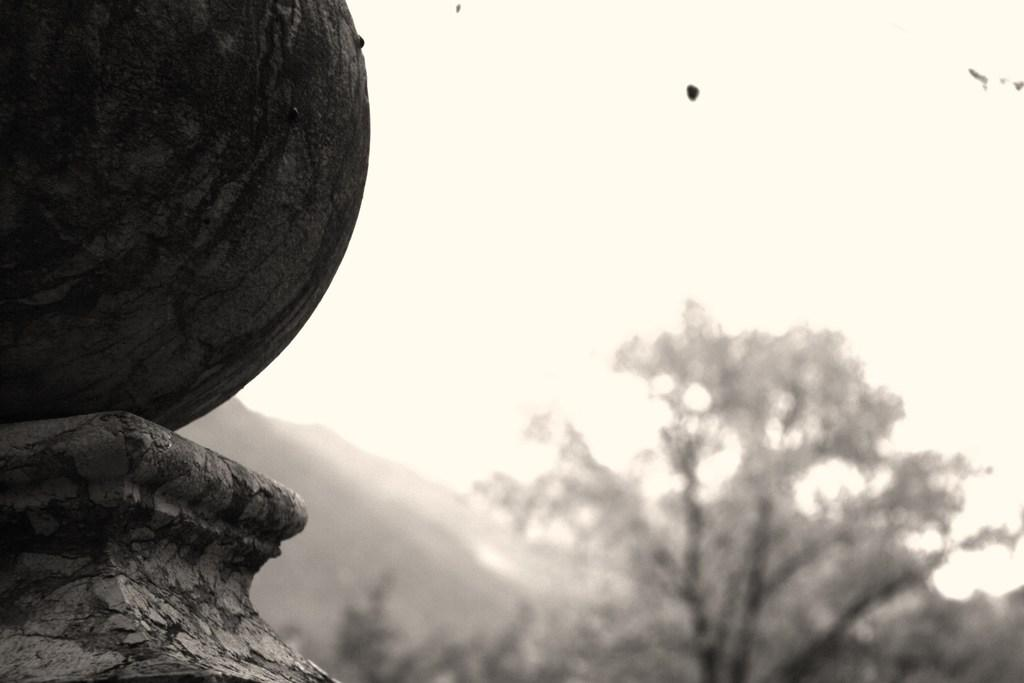What is the color scheme of the image? The image is black and white. What can be seen on the left side of the image? There is a spherical structure on the left side of the image. What type of natural element is visible in the background of the image? There is a tree in the background of the image. What is visible in the sky in the background of the image? The sky is visible in the background of the image. What is the distance between the tree and the spherical structure in the image? The provided facts do not give information about the distance between the tree and the spherical structure, so it cannot be determined from the image. 